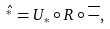Convert formula to latex. <formula><loc_0><loc_0><loc_500><loc_500>\hat { ^ { * } } = U _ { \ast } \circ R \circ \overline { - } ,</formula> 